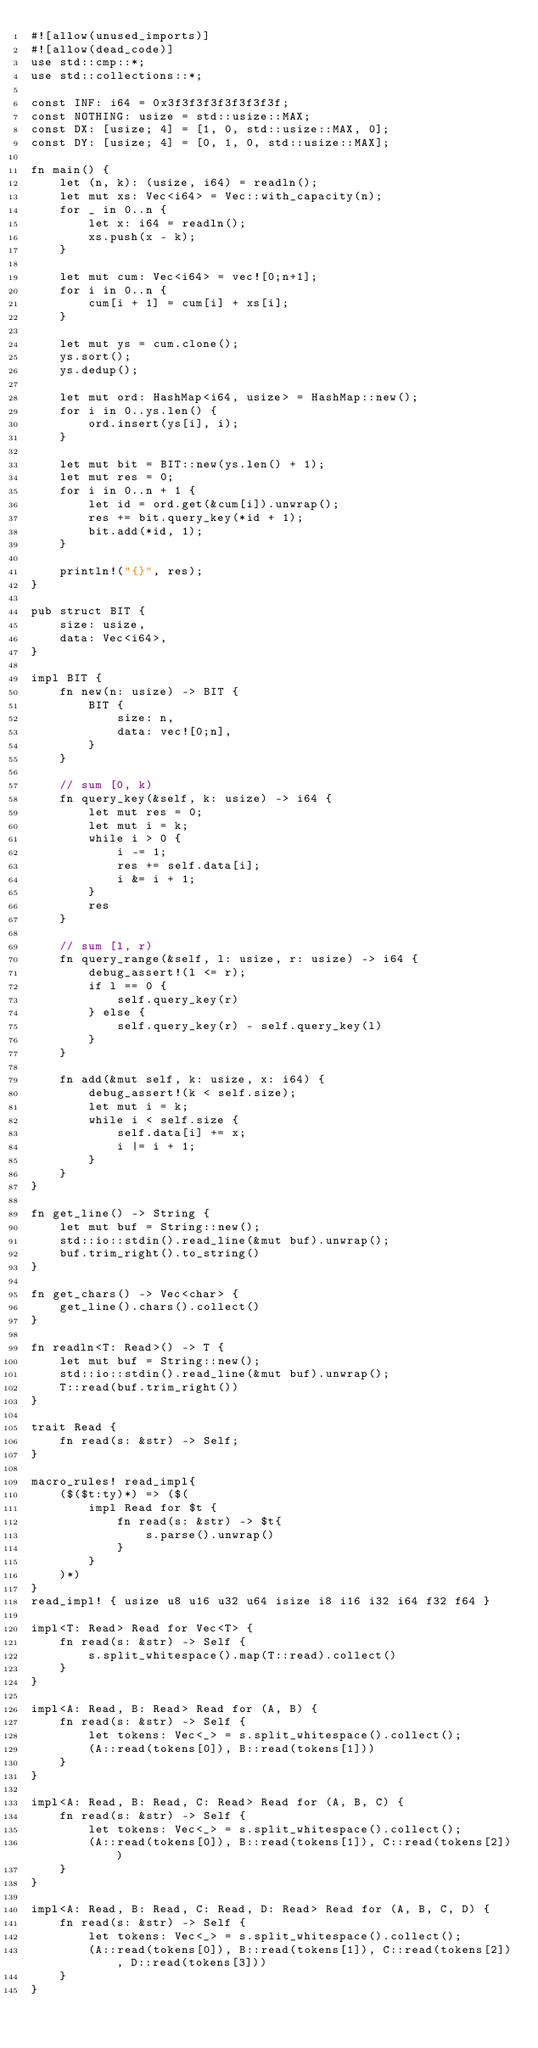Convert code to text. <code><loc_0><loc_0><loc_500><loc_500><_Rust_>#![allow(unused_imports)]
#![allow(dead_code)]
use std::cmp::*;
use std::collections::*;

const INF: i64 = 0x3f3f3f3f3f3f3f3f;
const NOTHING: usize = std::usize::MAX;
const DX: [usize; 4] = [1, 0, std::usize::MAX, 0];
const DY: [usize; 4] = [0, 1, 0, std::usize::MAX];

fn main() {
    let (n, k): (usize, i64) = readln();
    let mut xs: Vec<i64> = Vec::with_capacity(n);
    for _ in 0..n {
        let x: i64 = readln();
        xs.push(x - k);
    }

    let mut cum: Vec<i64> = vec![0;n+1];
    for i in 0..n {
        cum[i + 1] = cum[i] + xs[i];
    }

    let mut ys = cum.clone();
    ys.sort();
    ys.dedup();

    let mut ord: HashMap<i64, usize> = HashMap::new();
    for i in 0..ys.len() {
        ord.insert(ys[i], i);
    }

    let mut bit = BIT::new(ys.len() + 1);
    let mut res = 0;
    for i in 0..n + 1 {
        let id = ord.get(&cum[i]).unwrap();
        res += bit.query_key(*id + 1);
        bit.add(*id, 1);
    }

    println!("{}", res);
}

pub struct BIT {
    size: usize,
    data: Vec<i64>,
}

impl BIT {
    fn new(n: usize) -> BIT {
        BIT {
            size: n,
            data: vec![0;n],
        }
    }

    // sum [0, k)
    fn query_key(&self, k: usize) -> i64 {
        let mut res = 0;
        let mut i = k;
        while i > 0 {
            i -= 1;
            res += self.data[i];
            i &= i + 1;
        }
        res
    }

    // sum [l, r)
    fn query_range(&self, l: usize, r: usize) -> i64 {
        debug_assert!(l <= r);
        if l == 0 {
            self.query_key(r)
        } else {
            self.query_key(r) - self.query_key(l)
        }
    }

    fn add(&mut self, k: usize, x: i64) {
        debug_assert!(k < self.size);
        let mut i = k;
        while i < self.size {
            self.data[i] += x;
            i |= i + 1;
        }
    }
}

fn get_line() -> String {
    let mut buf = String::new();
    std::io::stdin().read_line(&mut buf).unwrap();
    buf.trim_right().to_string()
}

fn get_chars() -> Vec<char> {
    get_line().chars().collect()
}

fn readln<T: Read>() -> T {
    let mut buf = String::new();
    std::io::stdin().read_line(&mut buf).unwrap();
    T::read(buf.trim_right())
}

trait Read {
    fn read(s: &str) -> Self;
}

macro_rules! read_impl{
    ($($t:ty)*) => ($(
        impl Read for $t {
            fn read(s: &str) -> $t{
                s.parse().unwrap()
            }
        }
    )*)
}
read_impl! { usize u8 u16 u32 u64 isize i8 i16 i32 i64 f32 f64 }

impl<T: Read> Read for Vec<T> {
    fn read(s: &str) -> Self {
        s.split_whitespace().map(T::read).collect()
    }
}

impl<A: Read, B: Read> Read for (A, B) {
    fn read(s: &str) -> Self {
        let tokens: Vec<_> = s.split_whitespace().collect();
        (A::read(tokens[0]), B::read(tokens[1]))
    }
}

impl<A: Read, B: Read, C: Read> Read for (A, B, C) {
    fn read(s: &str) -> Self {
        let tokens: Vec<_> = s.split_whitespace().collect();
        (A::read(tokens[0]), B::read(tokens[1]), C::read(tokens[2]))
    }
}

impl<A: Read, B: Read, C: Read, D: Read> Read for (A, B, C, D) {
    fn read(s: &str) -> Self {
        let tokens: Vec<_> = s.split_whitespace().collect();
        (A::read(tokens[0]), B::read(tokens[1]), C::read(tokens[2]), D::read(tokens[3]))
    }
}</code> 